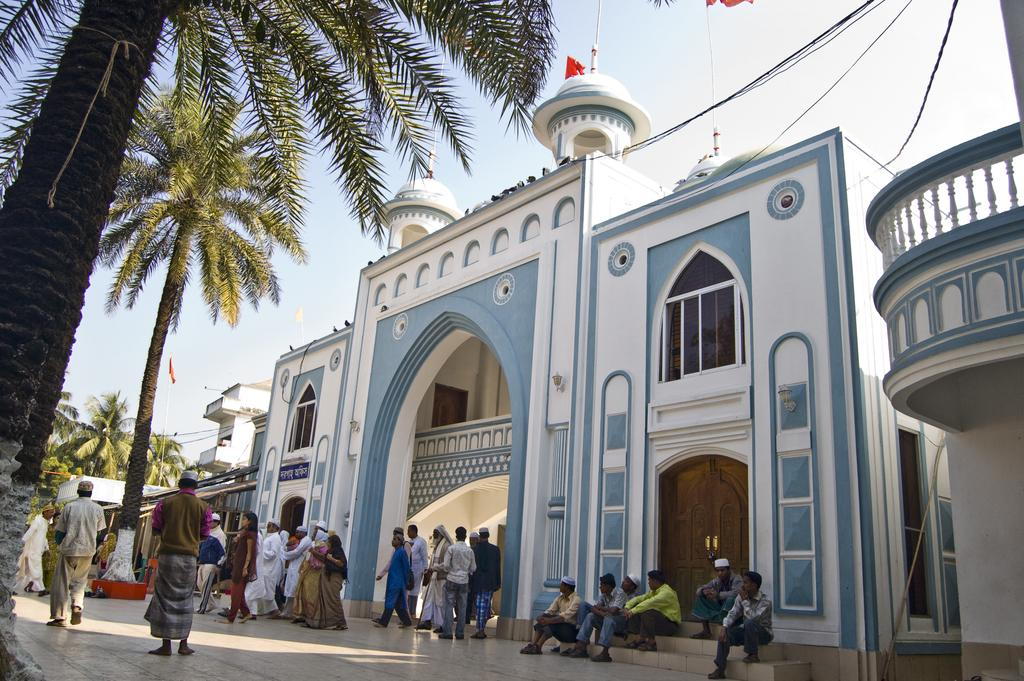Who or what can be seen in the image? There are people in the image. What structures are visible in the image? There are buildings in the image. What architectural features can be observed on the buildings? There are windows and doors visible on the buildings. What additional elements are present in the image? There are flags, wires, trees, and the sky visible in the image. What invention can be seen in the image? There is no specific invention mentioned or visible in the image. Can you describe the scent of the trees in the image? The image does not provide any information about the scent of the trees; it only shows their visual appearance. 